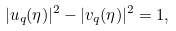<formula> <loc_0><loc_0><loc_500><loc_500>| u _ { q } ( \eta ) | ^ { 2 } - | v _ { q } ( \eta ) | ^ { 2 } = 1 ,</formula> 